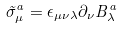Convert formula to latex. <formula><loc_0><loc_0><loc_500><loc_500>\tilde { \sigma } _ { \mu } ^ { a } = \epsilon _ { \mu \nu \lambda } \partial _ { \nu } B ^ { a } _ { \lambda }</formula> 